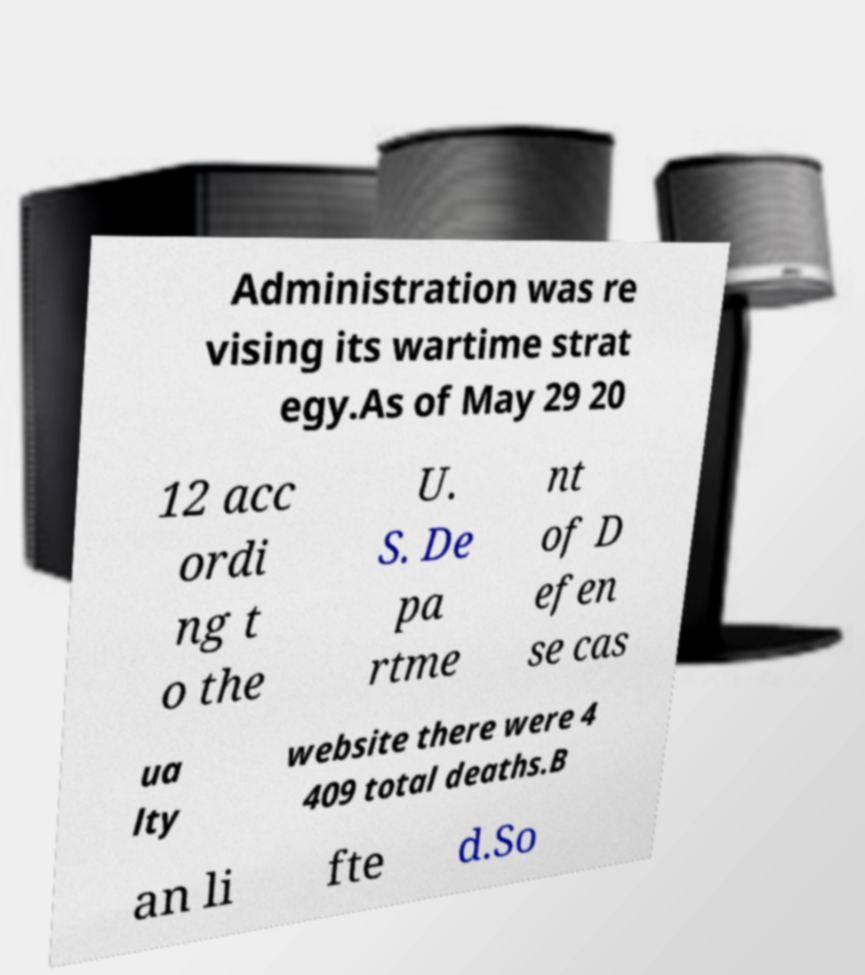There's text embedded in this image that I need extracted. Can you transcribe it verbatim? Administration was re vising its wartime strat egy.As of May 29 20 12 acc ordi ng t o the U. S. De pa rtme nt of D efen se cas ua lty website there were 4 409 total deaths.B an li fte d.So 